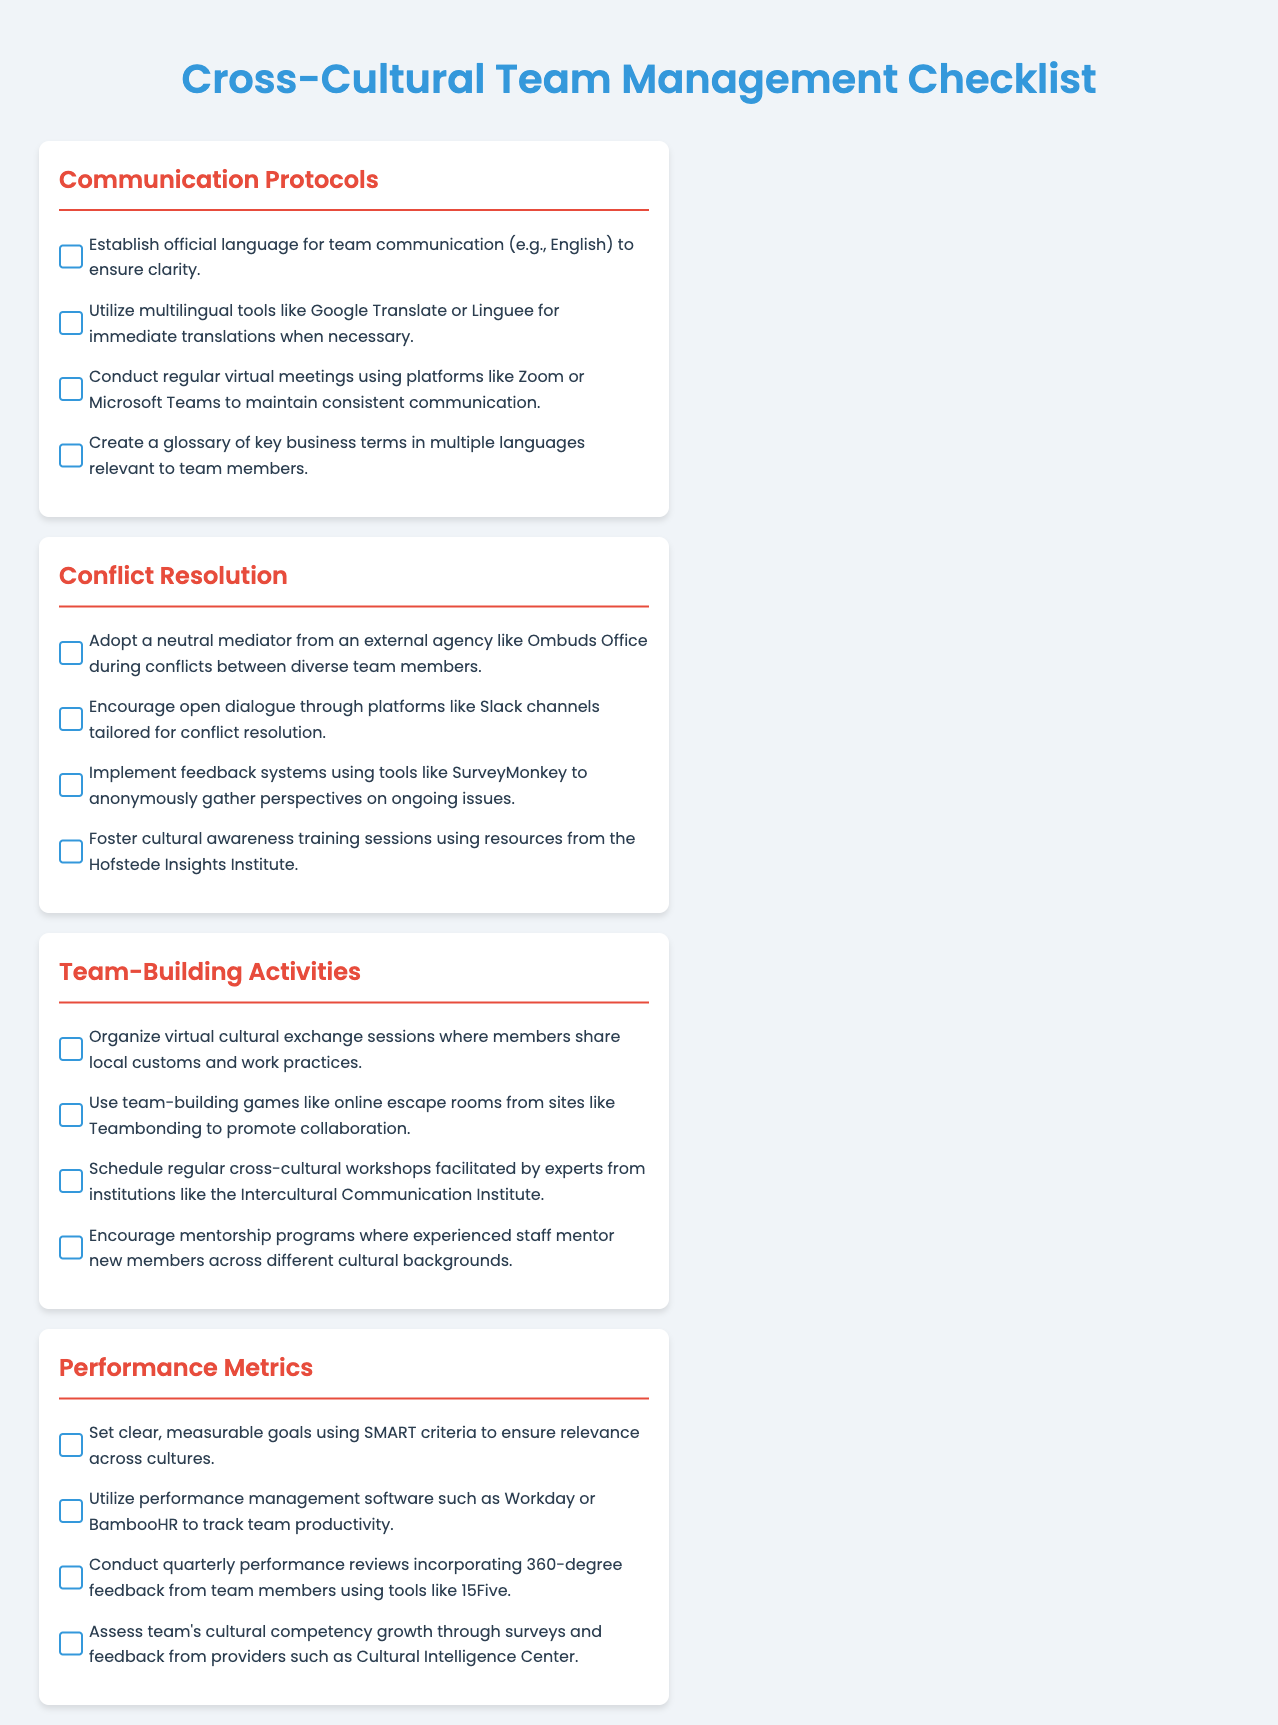what is the official language for team communication? The checklist specifies that the official language for team communication should be established to ensure clarity.
Answer: English what tool is suggested for multilingual translations? The document mentions using tools for immediate translations to help team members communicate effectively.
Answer: Google Translate which platform is recommended for regular virtual meetings? The checklist highlights a specific platform that facilitates consistent communication through virtual meetings.
Answer: Zoom what type of activities are suggested for team-building? The document lists various activities aimed at enhancing bonding among team members from different cultures.
Answer: virtual cultural exchange sessions how frequently should performance reviews be conducted? The checklist mentions a specific time frame for conducting team performance reviews to assess productivity and growth.
Answer: quarterly what is one tool suggested for performance management? The document advises using a particular software to help track team productivity and performance.
Answer: Workday who should facilitate cross-cultural workshops? The checklist specifies who should lead the team-building workshops to enhance cultural understanding among team members.
Answer: experts what feedback method is recommended for conflict resolution? The document suggests a method to gather anonymous perspectives on ongoing issues among diverse team members.
Answer: SurveyMonkey what type of training sessions does the checklist recommend? The document emphasizes the importance of a specific type of training to enhance cultural awareness among team members.
Answer: cultural awareness training sessions 